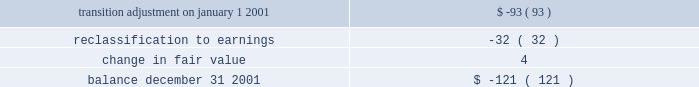Derivative instruments effective january 1 , 2001 , aes adopted sfas no .
133 , 2018 2018accounting for derivative instruments and hedging activities , 2019 2019 which , as amended , establishes accounting and reporting standards for derivative instruments and hedging activities .
The adoption of sfas no .
133 on january 1 , 2001 , resulted in a cumulative reduction to income of less than $ 1 million , net of deferred income tax effects , and a cumulative reduction of accumulated other comprehensive income in stockholders 2019 equity of $ 93 million , net of deferred income tax effects .
For the year ended december 31 , 2001 , the impact of changes in derivative fair value primarily related to derivatives that do not qualify for hedge accounting treatment was a charge of $ 36 million , after income taxes .
This amount includes a charge of $ 6 million , after income taxes , related to the ineffective portion of derivatives qualifying as cash flow and fair value hedges for the year ended december 31 , 2001 .
There was no net effect on results of operations for the year ended december 31 , 2001 , of derivative and non-derivative instruments that have been designated and qualified as hedging net investments in foreign operations .
Approximately $ 35 million of other comprehensive loss related to derivative instruments as of december 31 , 2001 is expected to be recognized as a reduction to earnings over the next twelve months .
A portion of this amount is expected to be offset by the effects of hedge accounting .
The balance in accumulated other comprehensive loss related to derivative transactions will be reclassified into earnings as interest expense is recognized for hedges of interest rate risk , as foreign currency transaction and translation gains and losses are recognized for hedges of foreign currency exposure and as electric and gas sales and purchases are recognized for hedges of forecasted electric and gas transactions .
Amounts recorded in accumulated other comprehensive income , net of tax , during the year-ended december 31 , 2001 , were as follows ( in millions ) : .
Aes utilizes derivative financial instruments to hedge interest rate risk , foreign exchange risk and commodity price risk .
The company utilizes interest rate swap , cap and floor agreements to hedge interest rate risk on floating rate debt .
The majority of aes 2019s interest rate derivatives are designated and qualify as cash flow hedges .
Currency forward and swap agreements are utilized to hedge foreign exchange risk which is a result of aes or one of its subsidiaries entering into monetary obligations in currencies other than its own functional currency .
The majority of aes 2019s foreign currency derivatives are designated and qualify as either fair value hedges or cash flow hedges .
Certain derivative instruments and other non-derivative instruments are designated and qualify as hedges of the foreign currency exposure of a net investment in a foreign operation .
The company utilizes electric and gas derivative instruments , including swaps , options , forwards and futures , to hedge the risk related to electricity and gas sales and purchases .
The majority of aes 2019s electric and gas derivatives are designated and qualify as cash flow hedges .
The maximum length of time over which aes is hedging its exposure to variability in future cash flows for forecasted transactions , excluding forecasted transactions related to the payment of variable interest , is three years .
For the year ended december 31 , 2001 , a charge of $ 4 million , after income taxes , was recorded for two cash flow hedges that were discontinued because it is probable that the hedged forecasted transaction will not occur .
A portion of this charge has been classified as discontinued operations .
For the year ended december 31 , 2001 , no fair value hedges were de-recognized or discontinued. .
Without the adjustment for the change in fair value , what would the aoci balance have been in millions at december 31 2001? 
Computations: (4 - 121)
Answer: -117.0. 